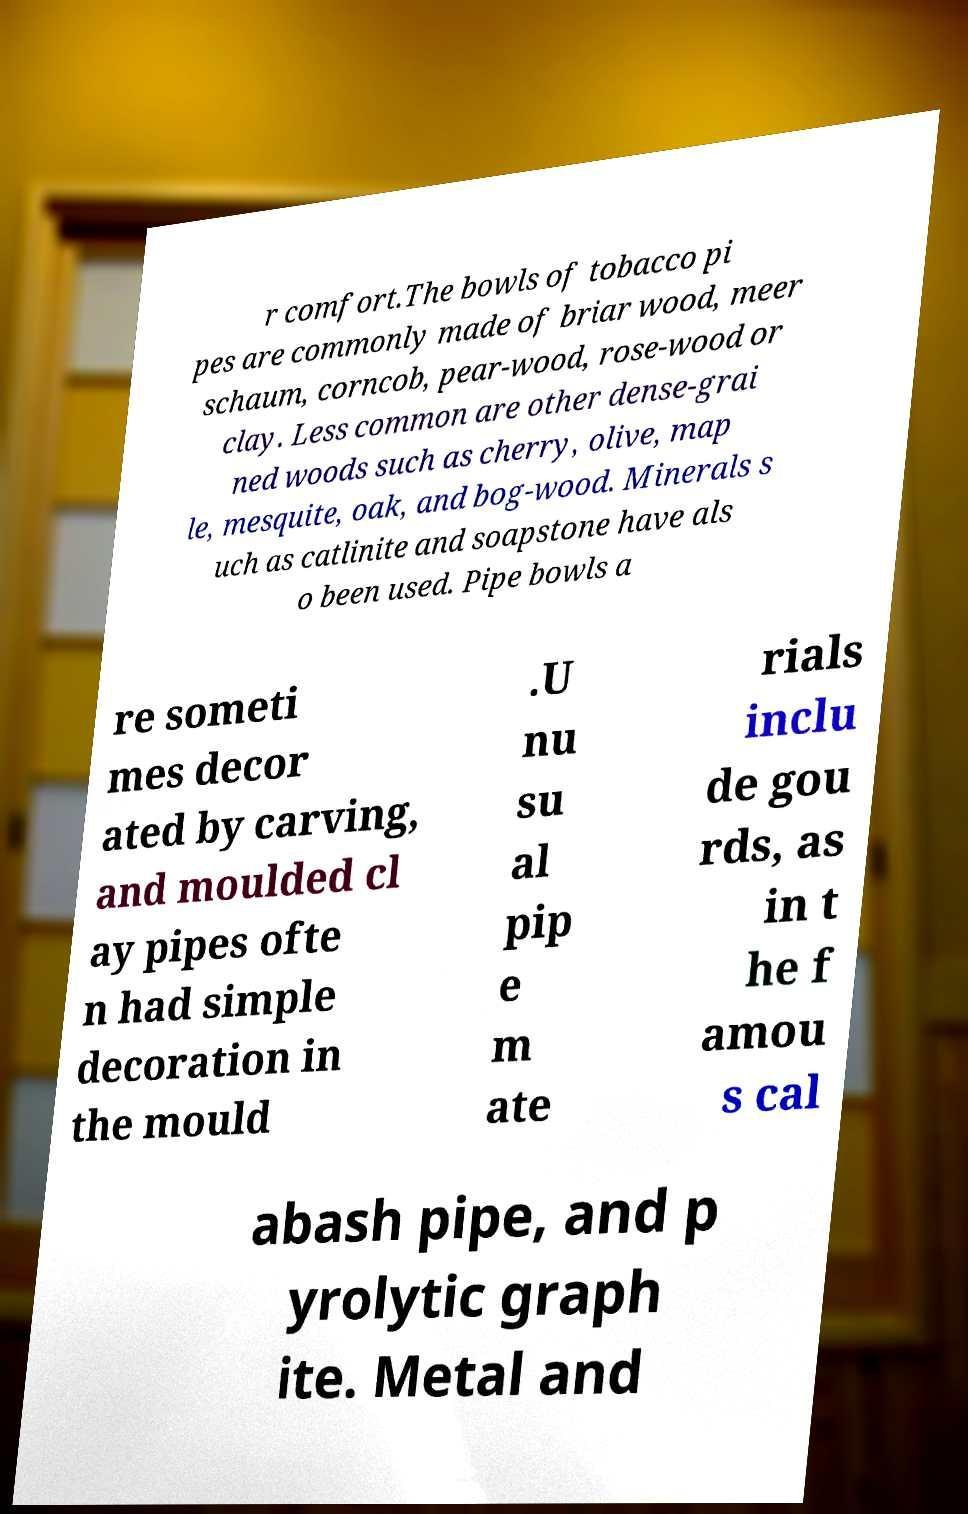Could you extract and type out the text from this image? r comfort.The bowls of tobacco pi pes are commonly made of briar wood, meer schaum, corncob, pear-wood, rose-wood or clay. Less common are other dense-grai ned woods such as cherry, olive, map le, mesquite, oak, and bog-wood. Minerals s uch as catlinite and soapstone have als o been used. Pipe bowls a re someti mes decor ated by carving, and moulded cl ay pipes ofte n had simple decoration in the mould .U nu su al pip e m ate rials inclu de gou rds, as in t he f amou s cal abash pipe, and p yrolytic graph ite. Metal and 